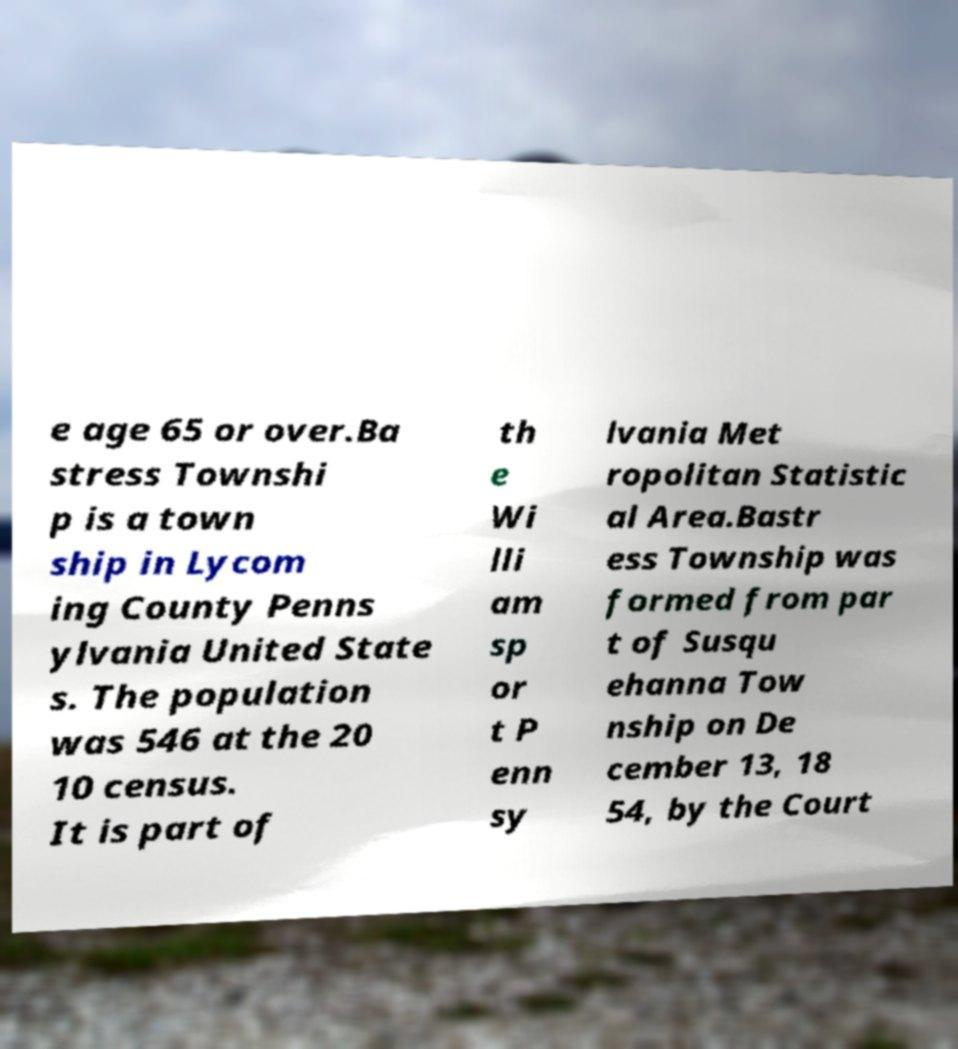Please identify and transcribe the text found in this image. e age 65 or over.Ba stress Townshi p is a town ship in Lycom ing County Penns ylvania United State s. The population was 546 at the 20 10 census. It is part of th e Wi lli am sp or t P enn sy lvania Met ropolitan Statistic al Area.Bastr ess Township was formed from par t of Susqu ehanna Tow nship on De cember 13, 18 54, by the Court 